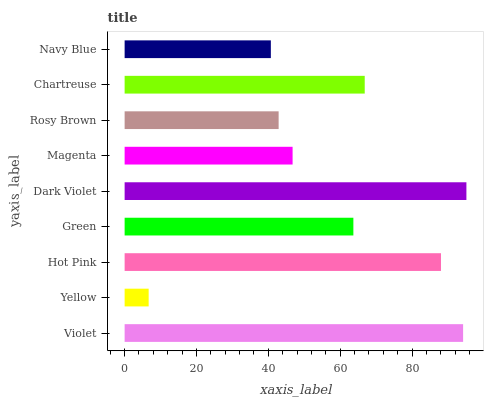Is Yellow the minimum?
Answer yes or no. Yes. Is Dark Violet the maximum?
Answer yes or no. Yes. Is Hot Pink the minimum?
Answer yes or no. No. Is Hot Pink the maximum?
Answer yes or no. No. Is Hot Pink greater than Yellow?
Answer yes or no. Yes. Is Yellow less than Hot Pink?
Answer yes or no. Yes. Is Yellow greater than Hot Pink?
Answer yes or no. No. Is Hot Pink less than Yellow?
Answer yes or no. No. Is Green the high median?
Answer yes or no. Yes. Is Green the low median?
Answer yes or no. Yes. Is Yellow the high median?
Answer yes or no. No. Is Dark Violet the low median?
Answer yes or no. No. 